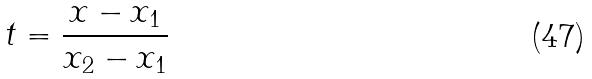Convert formula to latex. <formula><loc_0><loc_0><loc_500><loc_500>t = \frac { x - x _ { 1 } } { x _ { 2 } - x _ { 1 } }</formula> 